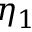Convert formula to latex. <formula><loc_0><loc_0><loc_500><loc_500>\eta _ { 1 }</formula> 